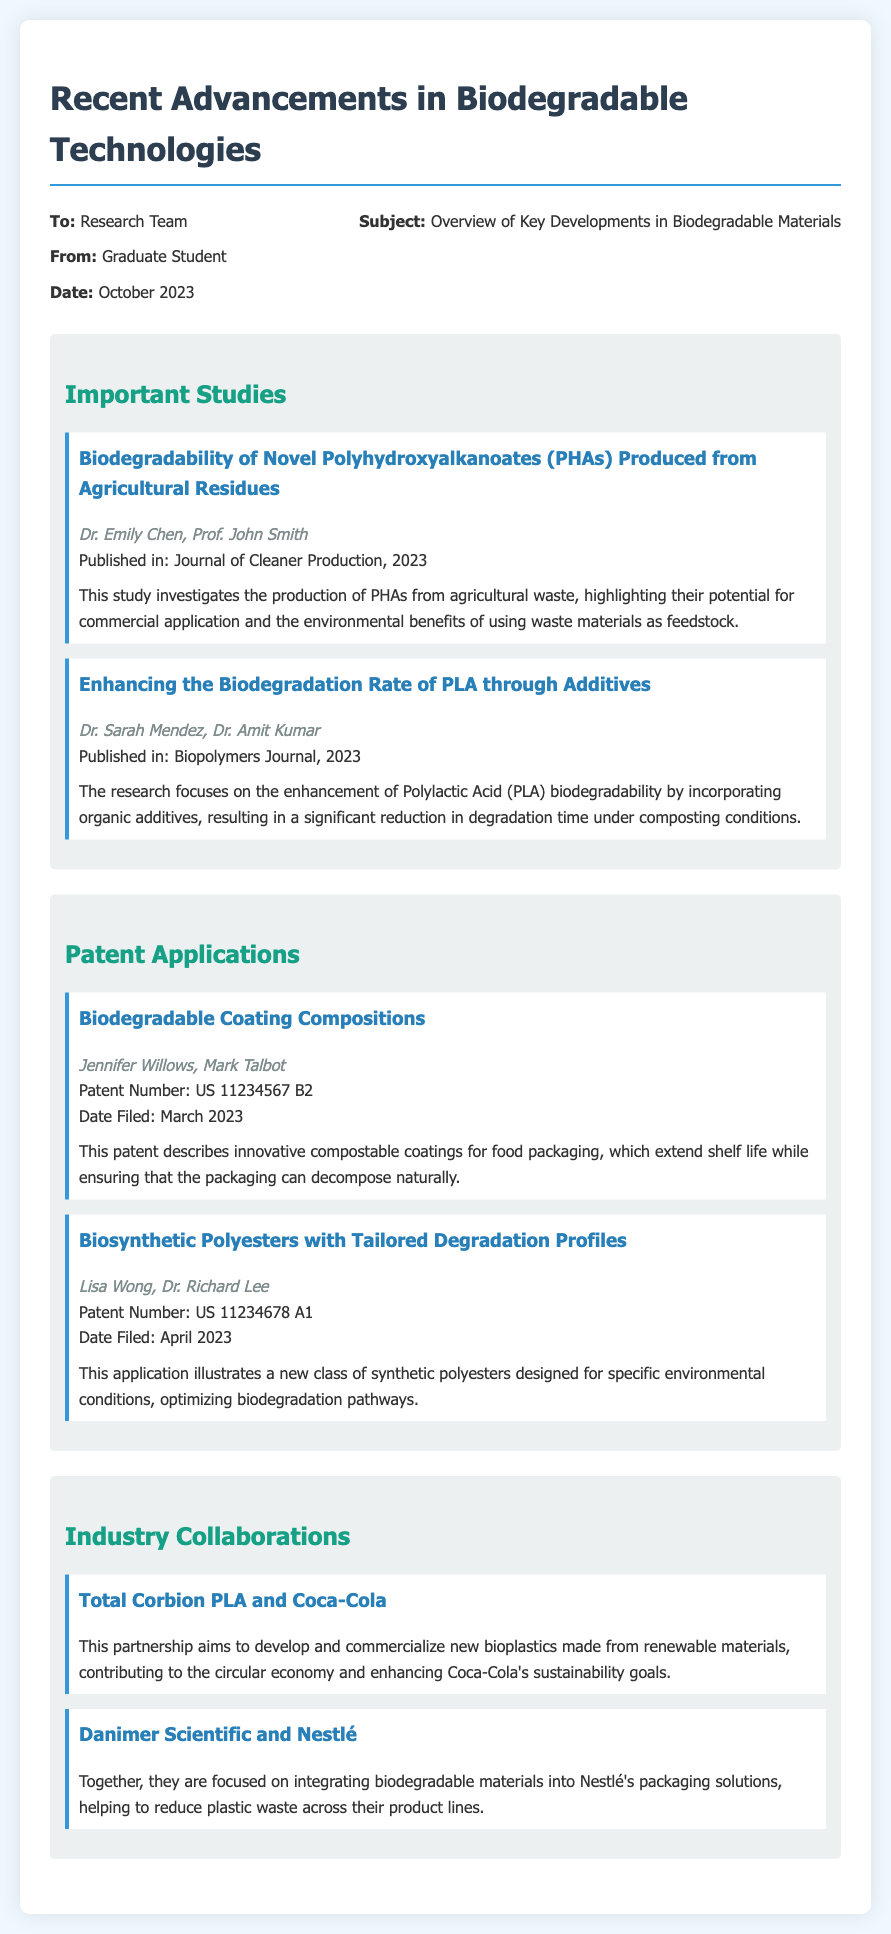What is the title of the first study? The title of the first study is located in the section for Important Studies.
Answer: Biodegradability of Novel Polyhydroxyalkanoates (PHAs) Produced from Agricultural Residues Who are the authors of the second study? The authors of the second study are mentioned right after the title of the study in the Important Studies section.
Answer: Dr. Sarah Mendez, Dr. Amit Kumar When was the patent for biodegradable coating compositions filed? The date filed is provided in the Patent Applications section for that specific patent.
Answer: March 2023 What is the patent number for the biosynthetic polyesters? The patent number is listed directly under the title in the Patent Applications section.
Answer: US 11234678 A1 What is the main focus of the collaboration between Danimer Scientific and Nestlé? The focus is outlined in the summary section for that collaboration in the Industry Collaborations section.
Answer: Integrating biodegradable materials into Nestlé's packaging solutions How many authors contributed to the first study? The authors' names are listed under the title, allowing the count of individual contributors.
Answer: Two What is emphasized by Total Corbion PLA and Coca-Cola's partnership? The summary for their collaboration highlights the objective of their work in the Industry Collaborations section.
Answer: Develop and commercialize new bioplastics made from renewable materials Which journal published the first study? The journal name is mentioned in the details provided for that study in the Important Studies section.
Answer: Journal of Cleaner Production 